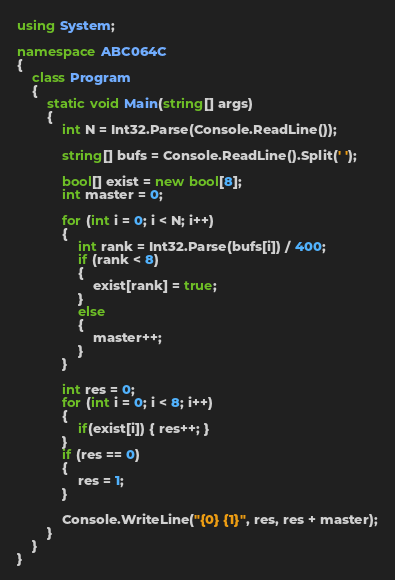<code> <loc_0><loc_0><loc_500><loc_500><_C#_>using System;

namespace ABC064C
{
    class Program
    {
        static void Main(string[] args)
        {
            int N = Int32.Parse(Console.ReadLine());

            string[] bufs = Console.ReadLine().Split(' ');

            bool[] exist = new bool[8];
            int master = 0;

            for (int i = 0; i < N; i++)
            {
                int rank = Int32.Parse(bufs[i]) / 400;
                if (rank < 8)
                {
                    exist[rank] = true;
                }
                else
                {
                    master++;
                }
            }

            int res = 0;
            for (int i = 0; i < 8; i++)
            {
                if(exist[i]) { res++; }
            }
            if (res == 0)
            {
                res = 1;
            }

            Console.WriteLine("{0} {1}", res, res + master);
        }
    }
}
</code> 